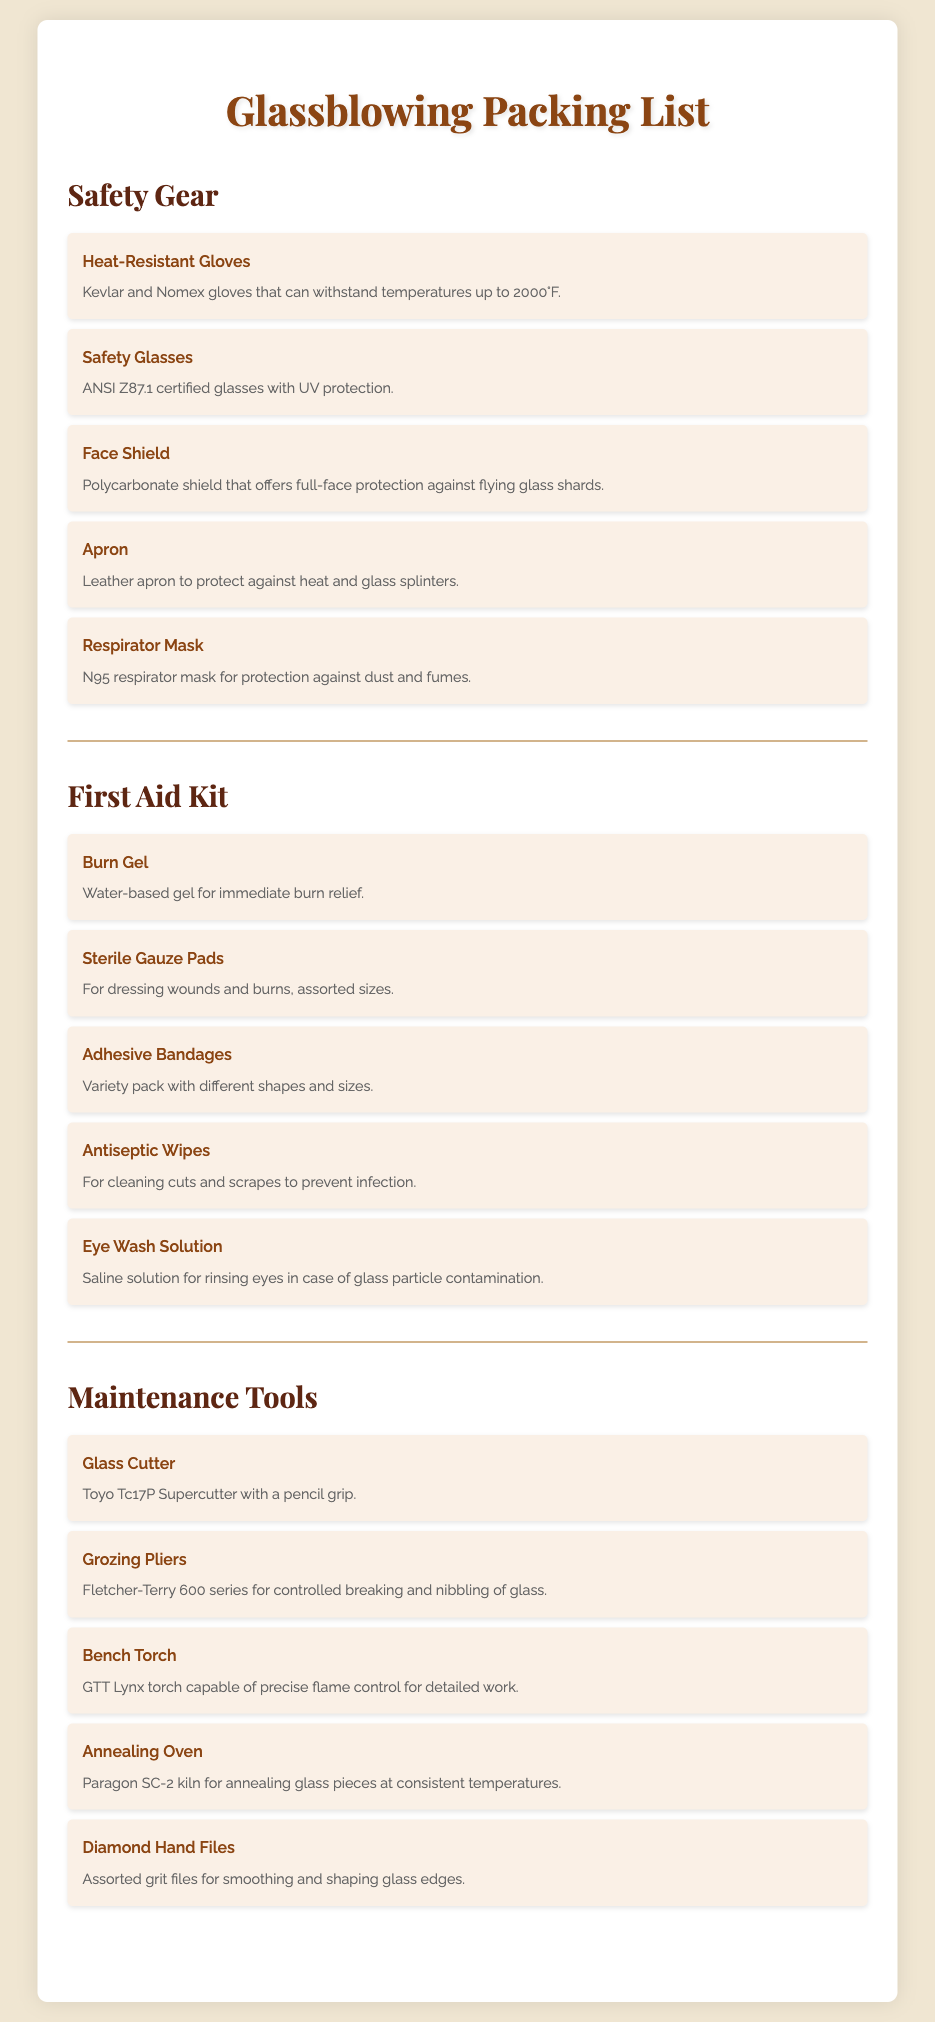What type of gloves are listed? The document specifies "Heat-Resistant Gloves" made of Kevlar and Nomex.
Answer: Heat-Resistant Gloves What is included in the First Aid Kit for burn relief? The document mentions "Burn Gel" as part of the First Aid Kit for immediate burn relief.
Answer: Burn Gel How many items are listed under Maintenance Tools? There are five items listed under the Maintenance Tools section in the document.
Answer: Five What is the purpose of the Face Shield? The Face Shield is designed to offer full-face protection against flying glass shards.
Answer: Full-face protection Which glove material can withstand temperatures up to 2000°F? The gloves are specifically made from Kevlar and Nomex, which can withstand high temperatures.
Answer: Kevlar and Nomex What type of eyewash solution is mentioned? The document states that "Eye Wash Solution" is a saline solution used for rinsing eyes.
Answer: Saline solution What is the item used for controlled breaking of glass? The document lists "Grozing Pliers" as the tool used for controlled breaking and nibbling of glass.
Answer: Grozing Pliers What kind of respirator is recommended? The document recommends using an "N95 respirator mask" for dust and fumes protection.
Answer: N95 respirator mask What kind of apron is included in the Safety Gear? The Safety Gear section mentions a "Leather apron" to protect against heat and glass splinters.
Answer: Leather apron 